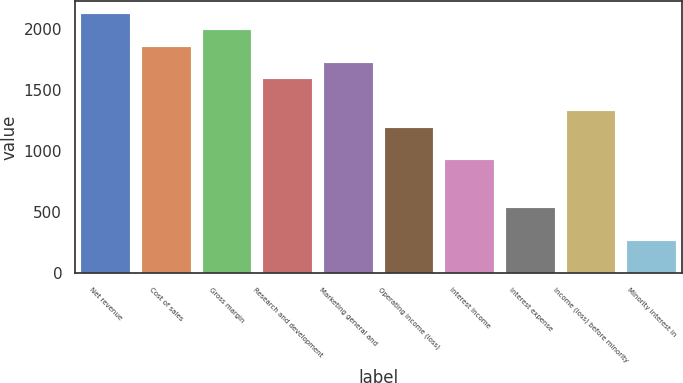Convert chart. <chart><loc_0><loc_0><loc_500><loc_500><bar_chart><fcel>Net revenue<fcel>Cost of sales<fcel>Gross margin<fcel>Research and development<fcel>Marketing general and<fcel>Operating income (loss)<fcel>Interest Income<fcel>Interest expense<fcel>Income (loss) before minority<fcel>Minority interest in<nl><fcel>2124.59<fcel>1859.05<fcel>1991.82<fcel>1593.51<fcel>1726.28<fcel>1195.2<fcel>929.66<fcel>531.35<fcel>1327.97<fcel>265.81<nl></chart> 